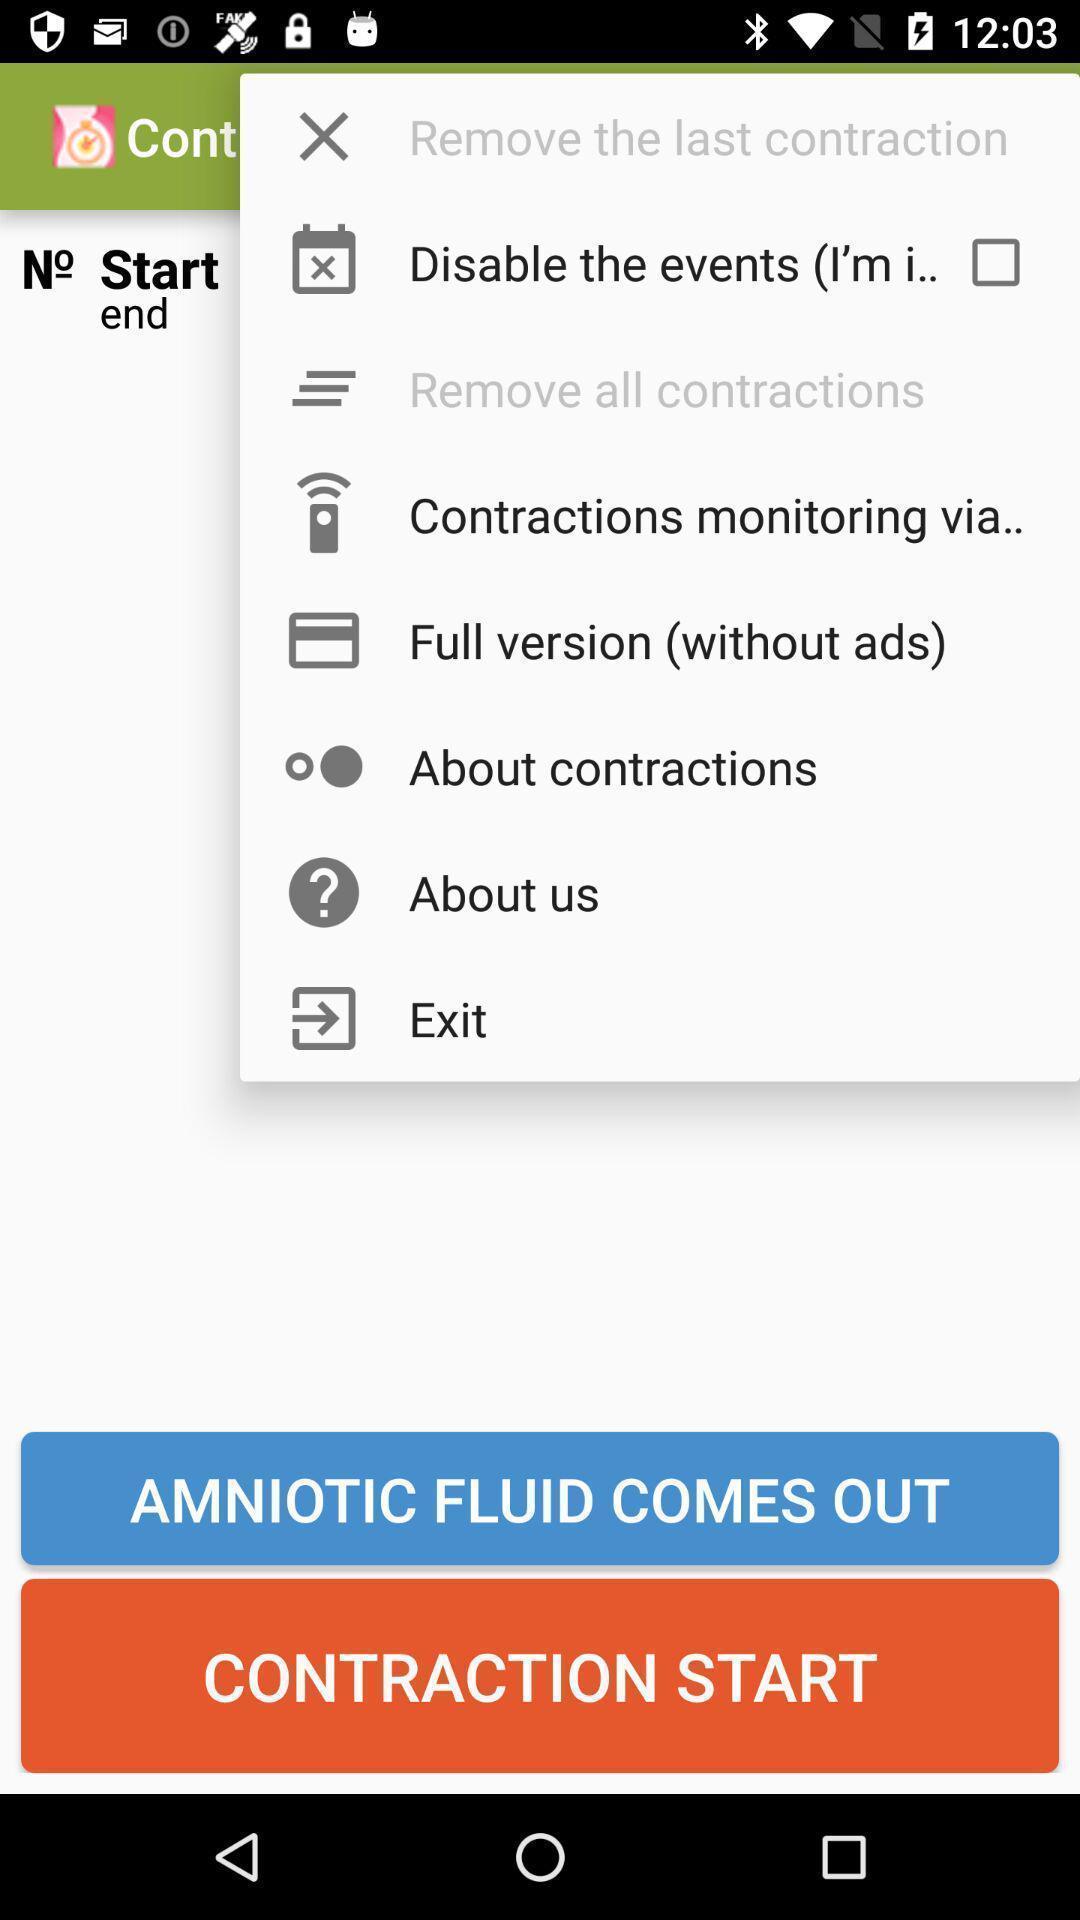Describe this image in words. Pop up displaying multiple settings options. 